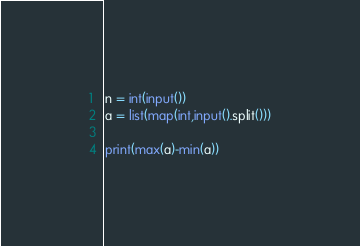<code> <loc_0><loc_0><loc_500><loc_500><_Python_>n = int(input())
a = list(map(int,input().split()))

print(max(a)-min(a))</code> 